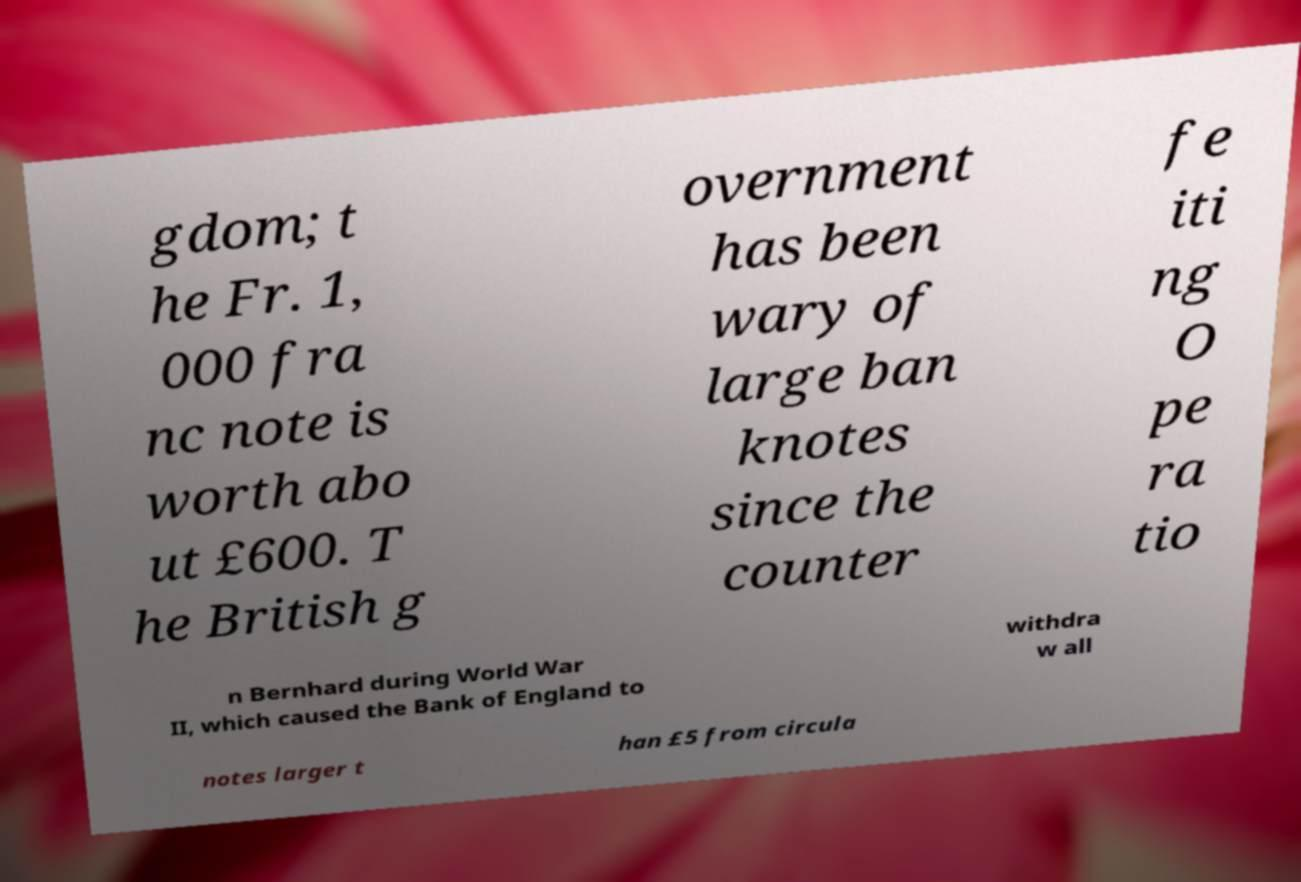For documentation purposes, I need the text within this image transcribed. Could you provide that? gdom; t he Fr. 1, 000 fra nc note is worth abo ut £600. T he British g overnment has been wary of large ban knotes since the counter fe iti ng O pe ra tio n Bernhard during World War II, which caused the Bank of England to withdra w all notes larger t han £5 from circula 